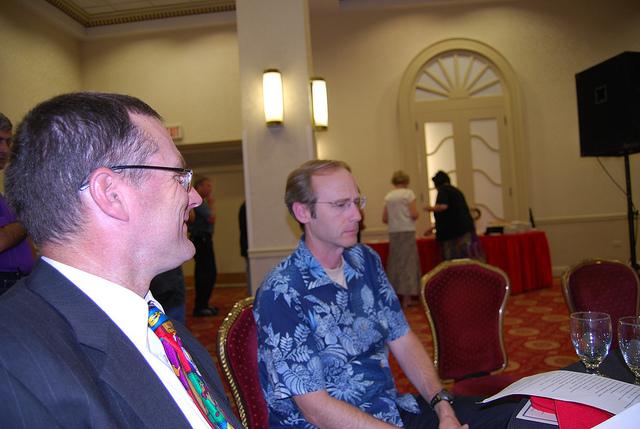Are these men happy?
Concise answer only. Yes. Does everyone look happy?
Short answer required. No. Does the man has blonde hair?
Keep it brief. No. Is this a party?
Be succinct. No. Is this a kids birthday party?
Be succinct. No. What color are the chairs?
Short answer required. Red. What are the women carrying?
Quick response, please. Food. What color is the man's glasses?
Keep it brief. Black. Why do the men look so serious?
Give a very brief answer. Meeting. Are they graduating?
Be succinct. No. How many women are visible in the background?
Keep it brief. 2. 